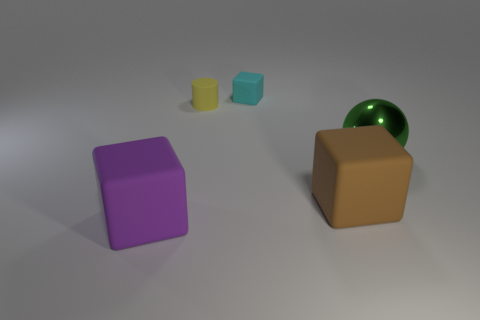Is there any other thing that has the same material as the green sphere?
Your response must be concise. No. How many other spheres are the same material as the large green sphere?
Give a very brief answer. 0. Is the shape of the large brown object the same as the small object behind the tiny yellow matte cylinder?
Your answer should be very brief. Yes. There is a cube behind the green sphere that is in front of the tiny cyan rubber cube; are there any tiny yellow matte cylinders to the left of it?
Provide a succinct answer. Yes. There is a rubber cube that is to the right of the cyan matte thing; what size is it?
Make the answer very short. Large. There is a green sphere that is the same size as the purple cube; what is its material?
Your answer should be compact. Metal. Do the cyan matte thing and the green object have the same shape?
Provide a succinct answer. No. What number of things are large red shiny cylinders or rubber objects in front of the tiny cube?
Keep it short and to the point. 3. Does the matte cube that is behind the green sphere have the same size as the small yellow rubber cylinder?
Provide a short and direct response. Yes. What number of large rubber objects are to the right of the large block that is on the left side of the cube behind the big green metal ball?
Ensure brevity in your answer.  1. 